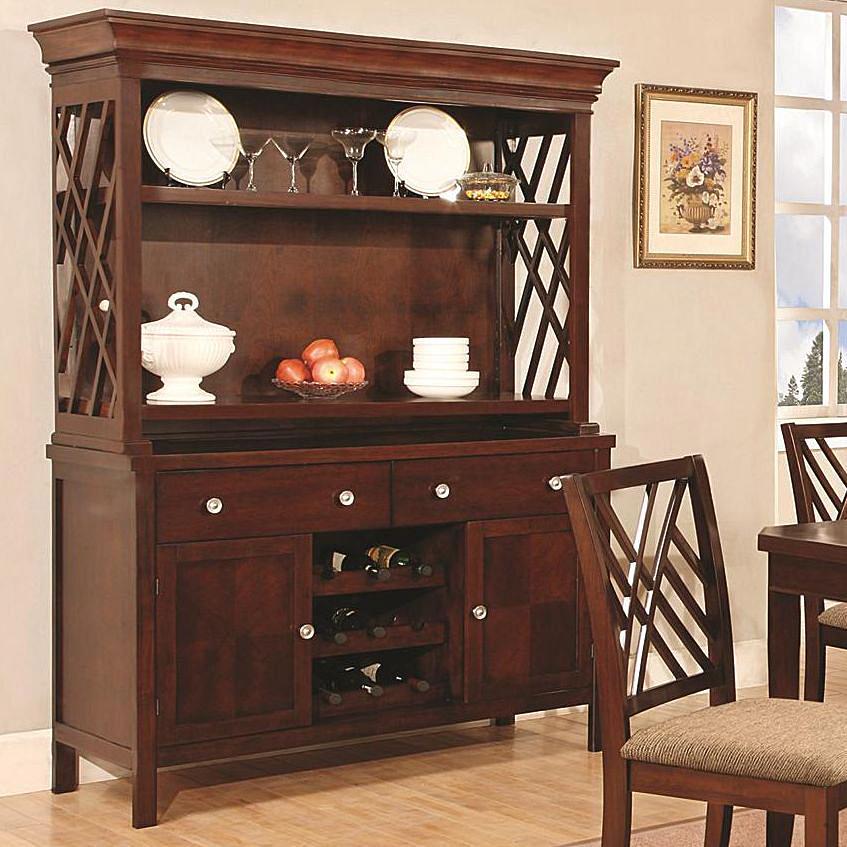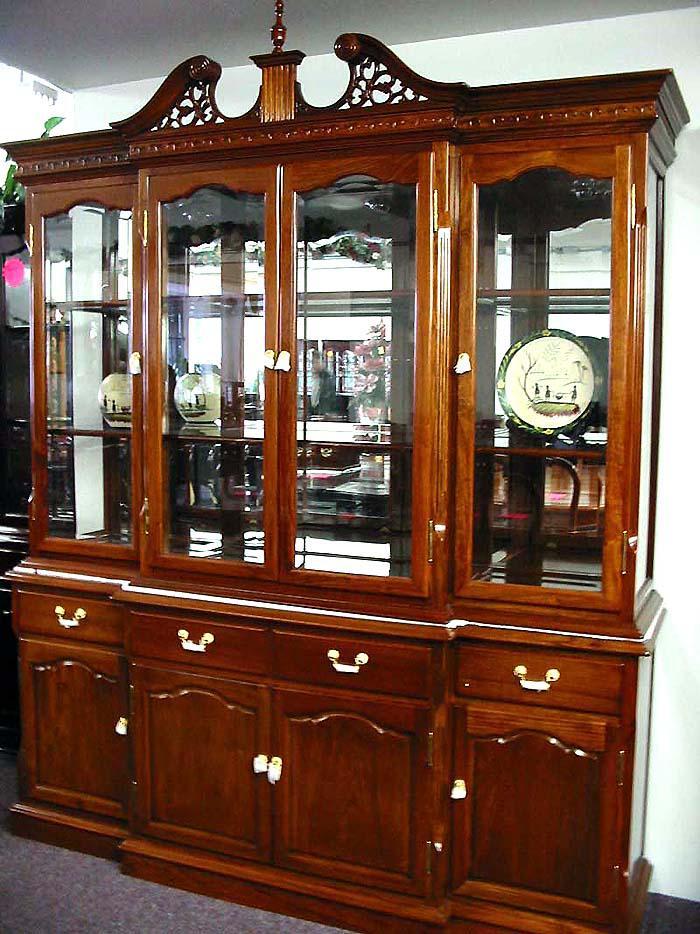The first image is the image on the left, the second image is the image on the right. Evaluate the accuracy of this statement regarding the images: "A brown wooden hutch has a flat top that extends beyond the cabinet, sits on short legs, and has been repurposed in the center bottom section to make a wine rack.". Is it true? Answer yes or no. Yes. The first image is the image on the left, the second image is the image on the right. Analyze the images presented: Is the assertion "In one image there is a single white Kitchen storage unit  that holds white bowls and cups." valid? Answer yes or no. No. The first image is the image on the left, the second image is the image on the right. For the images shown, is this caption "The right image contains a white china cabinet with glass doors." true? Answer yes or no. No. The first image is the image on the left, the second image is the image on the right. Given the left and right images, does the statement "The image on the right  contains a white wooden cabinet." hold true? Answer yes or no. No. 